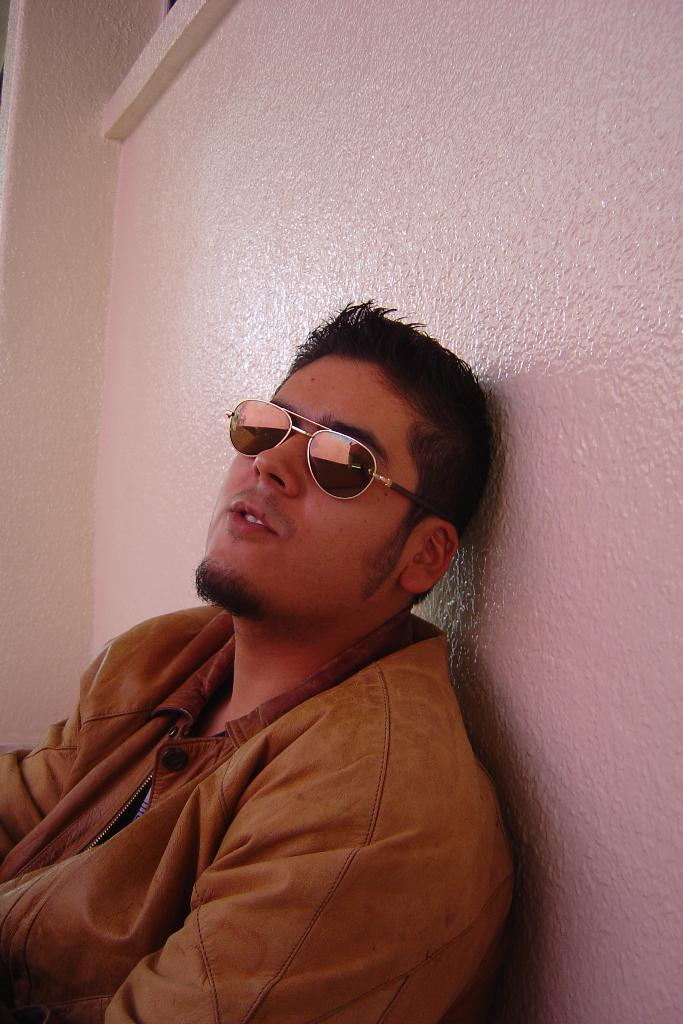Who is present in the image? There is a man in the image. What is the man wearing? The man is wearing a jacket. What can be seen in the background of the image? There is a wall in the background of the image. What type of fire can be seen in the maneuvering around the man in the image? There is no fire present in the image; it only features a man wearing a jacket with a wall in the background. 